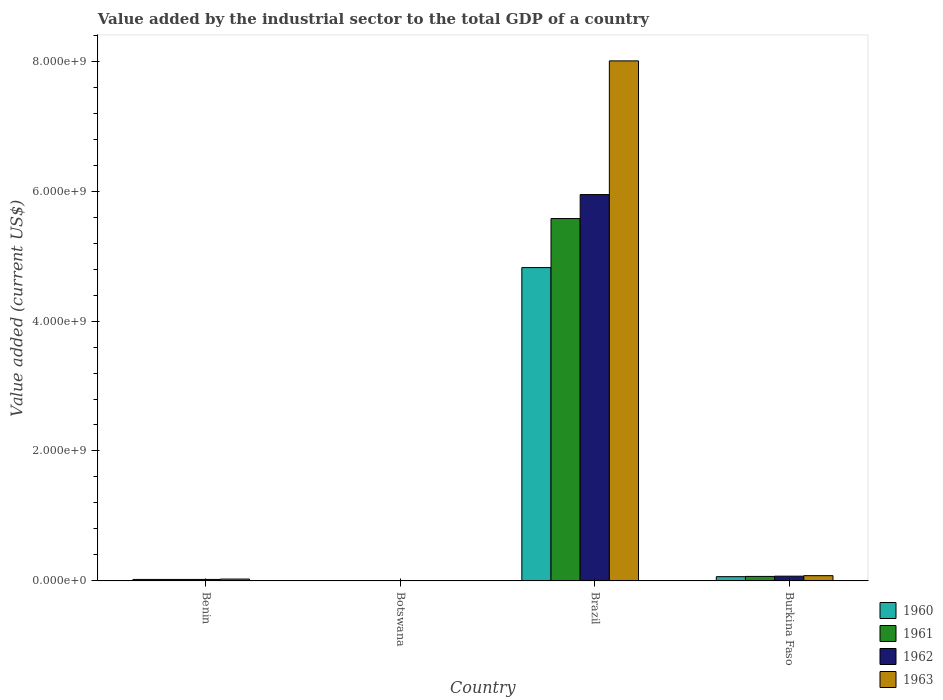How many different coloured bars are there?
Keep it short and to the point. 4. How many groups of bars are there?
Provide a succinct answer. 4. Are the number of bars on each tick of the X-axis equal?
Keep it short and to the point. Yes. In how many cases, is the number of bars for a given country not equal to the number of legend labels?
Provide a short and direct response. 0. What is the value added by the industrial sector to the total GDP in 1960 in Burkina Faso?
Your answer should be very brief. 6.58e+07. Across all countries, what is the maximum value added by the industrial sector to the total GDP in 1960?
Ensure brevity in your answer.  4.82e+09. Across all countries, what is the minimum value added by the industrial sector to the total GDP in 1962?
Offer a terse response. 4.05e+06. In which country was the value added by the industrial sector to the total GDP in 1963 maximum?
Give a very brief answer. Brazil. In which country was the value added by the industrial sector to the total GDP in 1961 minimum?
Offer a very short reply. Botswana. What is the total value added by the industrial sector to the total GDP in 1963 in the graph?
Offer a terse response. 8.12e+09. What is the difference between the value added by the industrial sector to the total GDP in 1962 in Botswana and that in Burkina Faso?
Offer a very short reply. -6.95e+07. What is the difference between the value added by the industrial sector to the total GDP in 1962 in Botswana and the value added by the industrial sector to the total GDP in 1961 in Brazil?
Keep it short and to the point. -5.57e+09. What is the average value added by the industrial sector to the total GDP in 1962 per country?
Keep it short and to the point. 1.51e+09. What is the difference between the value added by the industrial sector to the total GDP of/in 1963 and value added by the industrial sector to the total GDP of/in 1962 in Botswana?
Keep it short and to the point. -1.15e+04. What is the ratio of the value added by the industrial sector to the total GDP in 1963 in Botswana to that in Burkina Faso?
Offer a very short reply. 0.05. Is the value added by the industrial sector to the total GDP in 1961 in Botswana less than that in Brazil?
Keep it short and to the point. Yes. What is the difference between the highest and the second highest value added by the industrial sector to the total GDP in 1961?
Your answer should be compact. -4.66e+07. What is the difference between the highest and the lowest value added by the industrial sector to the total GDP in 1960?
Ensure brevity in your answer.  4.82e+09. Is it the case that in every country, the sum of the value added by the industrial sector to the total GDP in 1962 and value added by the industrial sector to the total GDP in 1963 is greater than the sum of value added by the industrial sector to the total GDP in 1960 and value added by the industrial sector to the total GDP in 1961?
Your answer should be compact. No. What does the 1st bar from the right in Burkina Faso represents?
Provide a short and direct response. 1963. Is it the case that in every country, the sum of the value added by the industrial sector to the total GDP in 1961 and value added by the industrial sector to the total GDP in 1962 is greater than the value added by the industrial sector to the total GDP in 1960?
Provide a succinct answer. Yes. How many bars are there?
Give a very brief answer. 16. Are all the bars in the graph horizontal?
Ensure brevity in your answer.  No. Are the values on the major ticks of Y-axis written in scientific E-notation?
Offer a very short reply. Yes. Does the graph contain grids?
Give a very brief answer. No. How are the legend labels stacked?
Offer a very short reply. Vertical. What is the title of the graph?
Your answer should be compact. Value added by the industrial sector to the total GDP of a country. Does "1998" appear as one of the legend labels in the graph?
Your response must be concise. No. What is the label or title of the X-axis?
Offer a very short reply. Country. What is the label or title of the Y-axis?
Make the answer very short. Value added (current US$). What is the Value added (current US$) in 1960 in Benin?
Provide a short and direct response. 2.31e+07. What is the Value added (current US$) of 1961 in Benin?
Your answer should be very brief. 2.31e+07. What is the Value added (current US$) of 1962 in Benin?
Provide a succinct answer. 2.32e+07. What is the Value added (current US$) in 1963 in Benin?
Ensure brevity in your answer.  2.91e+07. What is the Value added (current US$) of 1960 in Botswana?
Your answer should be very brief. 4.05e+06. What is the Value added (current US$) of 1961 in Botswana?
Provide a short and direct response. 4.05e+06. What is the Value added (current US$) in 1962 in Botswana?
Provide a succinct answer. 4.05e+06. What is the Value added (current US$) of 1963 in Botswana?
Your response must be concise. 4.04e+06. What is the Value added (current US$) in 1960 in Brazil?
Your response must be concise. 4.82e+09. What is the Value added (current US$) of 1961 in Brazil?
Provide a succinct answer. 5.58e+09. What is the Value added (current US$) of 1962 in Brazil?
Offer a very short reply. 5.95e+09. What is the Value added (current US$) in 1963 in Brazil?
Your answer should be very brief. 8.00e+09. What is the Value added (current US$) in 1960 in Burkina Faso?
Ensure brevity in your answer.  6.58e+07. What is the Value added (current US$) of 1961 in Burkina Faso?
Make the answer very short. 6.97e+07. What is the Value added (current US$) in 1962 in Burkina Faso?
Offer a very short reply. 7.35e+07. What is the Value added (current US$) in 1963 in Burkina Faso?
Make the answer very short. 8.13e+07. Across all countries, what is the maximum Value added (current US$) in 1960?
Ensure brevity in your answer.  4.82e+09. Across all countries, what is the maximum Value added (current US$) in 1961?
Keep it short and to the point. 5.58e+09. Across all countries, what is the maximum Value added (current US$) in 1962?
Ensure brevity in your answer.  5.95e+09. Across all countries, what is the maximum Value added (current US$) of 1963?
Keep it short and to the point. 8.00e+09. Across all countries, what is the minimum Value added (current US$) in 1960?
Your answer should be compact. 4.05e+06. Across all countries, what is the minimum Value added (current US$) in 1961?
Your response must be concise. 4.05e+06. Across all countries, what is the minimum Value added (current US$) in 1962?
Give a very brief answer. 4.05e+06. Across all countries, what is the minimum Value added (current US$) of 1963?
Keep it short and to the point. 4.04e+06. What is the total Value added (current US$) in 1960 in the graph?
Provide a short and direct response. 4.92e+09. What is the total Value added (current US$) of 1961 in the graph?
Make the answer very short. 5.67e+09. What is the total Value added (current US$) of 1962 in the graph?
Your response must be concise. 6.05e+09. What is the total Value added (current US$) in 1963 in the graph?
Provide a succinct answer. 8.12e+09. What is the difference between the Value added (current US$) of 1960 in Benin and that in Botswana?
Provide a short and direct response. 1.91e+07. What is the difference between the Value added (current US$) of 1961 in Benin and that in Botswana?
Provide a short and direct response. 1.91e+07. What is the difference between the Value added (current US$) of 1962 in Benin and that in Botswana?
Provide a succinct answer. 1.91e+07. What is the difference between the Value added (current US$) of 1963 in Benin and that in Botswana?
Give a very brief answer. 2.51e+07. What is the difference between the Value added (current US$) in 1960 in Benin and that in Brazil?
Keep it short and to the point. -4.80e+09. What is the difference between the Value added (current US$) of 1961 in Benin and that in Brazil?
Your answer should be very brief. -5.55e+09. What is the difference between the Value added (current US$) of 1962 in Benin and that in Brazil?
Keep it short and to the point. -5.92e+09. What is the difference between the Value added (current US$) in 1963 in Benin and that in Brazil?
Ensure brevity in your answer.  -7.97e+09. What is the difference between the Value added (current US$) of 1960 in Benin and that in Burkina Faso?
Provide a succinct answer. -4.27e+07. What is the difference between the Value added (current US$) of 1961 in Benin and that in Burkina Faso?
Your answer should be very brief. -4.66e+07. What is the difference between the Value added (current US$) in 1962 in Benin and that in Burkina Faso?
Your response must be concise. -5.04e+07. What is the difference between the Value added (current US$) of 1963 in Benin and that in Burkina Faso?
Offer a terse response. -5.21e+07. What is the difference between the Value added (current US$) of 1960 in Botswana and that in Brazil?
Offer a terse response. -4.82e+09. What is the difference between the Value added (current US$) of 1961 in Botswana and that in Brazil?
Your answer should be very brief. -5.57e+09. What is the difference between the Value added (current US$) in 1962 in Botswana and that in Brazil?
Ensure brevity in your answer.  -5.94e+09. What is the difference between the Value added (current US$) in 1963 in Botswana and that in Brazil?
Keep it short and to the point. -8.00e+09. What is the difference between the Value added (current US$) of 1960 in Botswana and that in Burkina Faso?
Keep it short and to the point. -6.17e+07. What is the difference between the Value added (current US$) in 1961 in Botswana and that in Burkina Faso?
Give a very brief answer. -6.56e+07. What is the difference between the Value added (current US$) of 1962 in Botswana and that in Burkina Faso?
Provide a short and direct response. -6.95e+07. What is the difference between the Value added (current US$) in 1963 in Botswana and that in Burkina Faso?
Provide a succinct answer. -7.72e+07. What is the difference between the Value added (current US$) of 1960 in Brazil and that in Burkina Faso?
Make the answer very short. 4.76e+09. What is the difference between the Value added (current US$) in 1961 in Brazil and that in Burkina Faso?
Ensure brevity in your answer.  5.51e+09. What is the difference between the Value added (current US$) of 1962 in Brazil and that in Burkina Faso?
Keep it short and to the point. 5.87e+09. What is the difference between the Value added (current US$) in 1963 in Brazil and that in Burkina Faso?
Offer a very short reply. 7.92e+09. What is the difference between the Value added (current US$) in 1960 in Benin and the Value added (current US$) in 1961 in Botswana?
Offer a terse response. 1.91e+07. What is the difference between the Value added (current US$) in 1960 in Benin and the Value added (current US$) in 1962 in Botswana?
Make the answer very short. 1.91e+07. What is the difference between the Value added (current US$) in 1960 in Benin and the Value added (current US$) in 1963 in Botswana?
Offer a terse response. 1.91e+07. What is the difference between the Value added (current US$) in 1961 in Benin and the Value added (current US$) in 1962 in Botswana?
Offer a terse response. 1.91e+07. What is the difference between the Value added (current US$) in 1961 in Benin and the Value added (current US$) in 1963 in Botswana?
Provide a succinct answer. 1.91e+07. What is the difference between the Value added (current US$) of 1962 in Benin and the Value added (current US$) of 1963 in Botswana?
Your answer should be very brief. 1.91e+07. What is the difference between the Value added (current US$) of 1960 in Benin and the Value added (current US$) of 1961 in Brazil?
Provide a short and direct response. -5.55e+09. What is the difference between the Value added (current US$) of 1960 in Benin and the Value added (current US$) of 1962 in Brazil?
Your response must be concise. -5.92e+09. What is the difference between the Value added (current US$) of 1960 in Benin and the Value added (current US$) of 1963 in Brazil?
Give a very brief answer. -7.98e+09. What is the difference between the Value added (current US$) in 1961 in Benin and the Value added (current US$) in 1962 in Brazil?
Offer a terse response. -5.92e+09. What is the difference between the Value added (current US$) of 1961 in Benin and the Value added (current US$) of 1963 in Brazil?
Offer a terse response. -7.98e+09. What is the difference between the Value added (current US$) in 1962 in Benin and the Value added (current US$) in 1963 in Brazil?
Keep it short and to the point. -7.98e+09. What is the difference between the Value added (current US$) in 1960 in Benin and the Value added (current US$) in 1961 in Burkina Faso?
Make the answer very short. -4.65e+07. What is the difference between the Value added (current US$) of 1960 in Benin and the Value added (current US$) of 1962 in Burkina Faso?
Your answer should be very brief. -5.04e+07. What is the difference between the Value added (current US$) in 1960 in Benin and the Value added (current US$) in 1963 in Burkina Faso?
Your answer should be very brief. -5.81e+07. What is the difference between the Value added (current US$) of 1961 in Benin and the Value added (current US$) of 1962 in Burkina Faso?
Give a very brief answer. -5.04e+07. What is the difference between the Value added (current US$) of 1961 in Benin and the Value added (current US$) of 1963 in Burkina Faso?
Your answer should be very brief. -5.81e+07. What is the difference between the Value added (current US$) in 1962 in Benin and the Value added (current US$) in 1963 in Burkina Faso?
Your response must be concise. -5.81e+07. What is the difference between the Value added (current US$) in 1960 in Botswana and the Value added (current US$) in 1961 in Brazil?
Offer a terse response. -5.57e+09. What is the difference between the Value added (current US$) of 1960 in Botswana and the Value added (current US$) of 1962 in Brazil?
Make the answer very short. -5.94e+09. What is the difference between the Value added (current US$) of 1960 in Botswana and the Value added (current US$) of 1963 in Brazil?
Your answer should be compact. -8.00e+09. What is the difference between the Value added (current US$) in 1961 in Botswana and the Value added (current US$) in 1962 in Brazil?
Offer a very short reply. -5.94e+09. What is the difference between the Value added (current US$) of 1961 in Botswana and the Value added (current US$) of 1963 in Brazil?
Offer a very short reply. -8.00e+09. What is the difference between the Value added (current US$) of 1962 in Botswana and the Value added (current US$) of 1963 in Brazil?
Provide a succinct answer. -8.00e+09. What is the difference between the Value added (current US$) of 1960 in Botswana and the Value added (current US$) of 1961 in Burkina Faso?
Your response must be concise. -6.56e+07. What is the difference between the Value added (current US$) of 1960 in Botswana and the Value added (current US$) of 1962 in Burkina Faso?
Offer a very short reply. -6.95e+07. What is the difference between the Value added (current US$) of 1960 in Botswana and the Value added (current US$) of 1963 in Burkina Faso?
Give a very brief answer. -7.72e+07. What is the difference between the Value added (current US$) of 1961 in Botswana and the Value added (current US$) of 1962 in Burkina Faso?
Your answer should be very brief. -6.95e+07. What is the difference between the Value added (current US$) of 1961 in Botswana and the Value added (current US$) of 1963 in Burkina Faso?
Your answer should be compact. -7.72e+07. What is the difference between the Value added (current US$) in 1962 in Botswana and the Value added (current US$) in 1963 in Burkina Faso?
Offer a terse response. -7.72e+07. What is the difference between the Value added (current US$) in 1960 in Brazil and the Value added (current US$) in 1961 in Burkina Faso?
Your response must be concise. 4.75e+09. What is the difference between the Value added (current US$) in 1960 in Brazil and the Value added (current US$) in 1962 in Burkina Faso?
Provide a succinct answer. 4.75e+09. What is the difference between the Value added (current US$) in 1960 in Brazil and the Value added (current US$) in 1963 in Burkina Faso?
Give a very brief answer. 4.74e+09. What is the difference between the Value added (current US$) in 1961 in Brazil and the Value added (current US$) in 1962 in Burkina Faso?
Make the answer very short. 5.50e+09. What is the difference between the Value added (current US$) in 1961 in Brazil and the Value added (current US$) in 1963 in Burkina Faso?
Provide a succinct answer. 5.50e+09. What is the difference between the Value added (current US$) of 1962 in Brazil and the Value added (current US$) of 1963 in Burkina Faso?
Your answer should be compact. 5.86e+09. What is the average Value added (current US$) in 1960 per country?
Provide a short and direct response. 1.23e+09. What is the average Value added (current US$) in 1961 per country?
Keep it short and to the point. 1.42e+09. What is the average Value added (current US$) in 1962 per country?
Make the answer very short. 1.51e+09. What is the average Value added (current US$) in 1963 per country?
Your answer should be compact. 2.03e+09. What is the difference between the Value added (current US$) of 1960 and Value added (current US$) of 1961 in Benin?
Offer a very short reply. 6130.83. What is the difference between the Value added (current US$) in 1960 and Value added (current US$) in 1962 in Benin?
Offer a very short reply. -1.71e+04. What is the difference between the Value added (current US$) of 1960 and Value added (current US$) of 1963 in Benin?
Your response must be concise. -5.99e+06. What is the difference between the Value added (current US$) of 1961 and Value added (current US$) of 1962 in Benin?
Offer a very short reply. -2.32e+04. What is the difference between the Value added (current US$) of 1961 and Value added (current US$) of 1963 in Benin?
Give a very brief answer. -6.00e+06. What is the difference between the Value added (current US$) in 1962 and Value added (current US$) in 1963 in Benin?
Offer a very short reply. -5.97e+06. What is the difference between the Value added (current US$) in 1960 and Value added (current US$) in 1961 in Botswana?
Keep it short and to the point. 7791.27. What is the difference between the Value added (current US$) in 1960 and Value added (current US$) in 1962 in Botswana?
Ensure brevity in your answer.  -314.81. What is the difference between the Value added (current US$) of 1960 and Value added (current US$) of 1963 in Botswana?
Make the answer very short. 1.11e+04. What is the difference between the Value added (current US$) in 1961 and Value added (current US$) in 1962 in Botswana?
Keep it short and to the point. -8106.08. What is the difference between the Value added (current US$) in 1961 and Value added (current US$) in 1963 in Botswana?
Provide a short and direct response. 3353.04. What is the difference between the Value added (current US$) in 1962 and Value added (current US$) in 1963 in Botswana?
Offer a very short reply. 1.15e+04. What is the difference between the Value added (current US$) in 1960 and Value added (current US$) in 1961 in Brazil?
Your response must be concise. -7.55e+08. What is the difference between the Value added (current US$) of 1960 and Value added (current US$) of 1962 in Brazil?
Your answer should be very brief. -1.12e+09. What is the difference between the Value added (current US$) of 1960 and Value added (current US$) of 1963 in Brazil?
Your response must be concise. -3.18e+09. What is the difference between the Value added (current US$) in 1961 and Value added (current US$) in 1962 in Brazil?
Offer a terse response. -3.69e+08. What is the difference between the Value added (current US$) in 1961 and Value added (current US$) in 1963 in Brazil?
Provide a short and direct response. -2.43e+09. What is the difference between the Value added (current US$) of 1962 and Value added (current US$) of 1963 in Brazil?
Make the answer very short. -2.06e+09. What is the difference between the Value added (current US$) in 1960 and Value added (current US$) in 1961 in Burkina Faso?
Offer a terse response. -3.88e+06. What is the difference between the Value added (current US$) in 1960 and Value added (current US$) in 1962 in Burkina Faso?
Your response must be concise. -7.71e+06. What is the difference between the Value added (current US$) in 1960 and Value added (current US$) in 1963 in Burkina Faso?
Your response must be concise. -1.55e+07. What is the difference between the Value added (current US$) in 1961 and Value added (current US$) in 1962 in Burkina Faso?
Offer a terse response. -3.83e+06. What is the difference between the Value added (current US$) of 1961 and Value added (current US$) of 1963 in Burkina Faso?
Provide a succinct answer. -1.16e+07. What is the difference between the Value added (current US$) in 1962 and Value added (current US$) in 1963 in Burkina Faso?
Offer a terse response. -7.75e+06. What is the ratio of the Value added (current US$) of 1960 in Benin to that in Botswana?
Ensure brevity in your answer.  5.71. What is the ratio of the Value added (current US$) in 1961 in Benin to that in Botswana?
Make the answer very short. 5.72. What is the ratio of the Value added (current US$) in 1962 in Benin to that in Botswana?
Offer a very short reply. 5.71. What is the ratio of the Value added (current US$) of 1963 in Benin to that in Botswana?
Offer a terse response. 7.2. What is the ratio of the Value added (current US$) of 1960 in Benin to that in Brazil?
Keep it short and to the point. 0. What is the ratio of the Value added (current US$) in 1961 in Benin to that in Brazil?
Offer a terse response. 0. What is the ratio of the Value added (current US$) in 1962 in Benin to that in Brazil?
Give a very brief answer. 0. What is the ratio of the Value added (current US$) of 1963 in Benin to that in Brazil?
Your answer should be compact. 0. What is the ratio of the Value added (current US$) in 1960 in Benin to that in Burkina Faso?
Provide a succinct answer. 0.35. What is the ratio of the Value added (current US$) in 1961 in Benin to that in Burkina Faso?
Your answer should be compact. 0.33. What is the ratio of the Value added (current US$) of 1962 in Benin to that in Burkina Faso?
Your response must be concise. 0.31. What is the ratio of the Value added (current US$) of 1963 in Benin to that in Burkina Faso?
Your answer should be compact. 0.36. What is the ratio of the Value added (current US$) in 1960 in Botswana to that in Brazil?
Provide a short and direct response. 0. What is the ratio of the Value added (current US$) in 1961 in Botswana to that in Brazil?
Offer a very short reply. 0. What is the ratio of the Value added (current US$) of 1962 in Botswana to that in Brazil?
Offer a very short reply. 0. What is the ratio of the Value added (current US$) of 1963 in Botswana to that in Brazil?
Provide a short and direct response. 0. What is the ratio of the Value added (current US$) in 1960 in Botswana to that in Burkina Faso?
Make the answer very short. 0.06. What is the ratio of the Value added (current US$) in 1961 in Botswana to that in Burkina Faso?
Make the answer very short. 0.06. What is the ratio of the Value added (current US$) in 1962 in Botswana to that in Burkina Faso?
Keep it short and to the point. 0.06. What is the ratio of the Value added (current US$) of 1963 in Botswana to that in Burkina Faso?
Your answer should be compact. 0.05. What is the ratio of the Value added (current US$) of 1960 in Brazil to that in Burkina Faso?
Ensure brevity in your answer.  73.29. What is the ratio of the Value added (current US$) in 1961 in Brazil to that in Burkina Faso?
Give a very brief answer. 80.04. What is the ratio of the Value added (current US$) in 1962 in Brazil to that in Burkina Faso?
Your response must be concise. 80.89. What is the ratio of the Value added (current US$) in 1963 in Brazil to that in Burkina Faso?
Your response must be concise. 98.49. What is the difference between the highest and the second highest Value added (current US$) in 1960?
Offer a very short reply. 4.76e+09. What is the difference between the highest and the second highest Value added (current US$) in 1961?
Your answer should be very brief. 5.51e+09. What is the difference between the highest and the second highest Value added (current US$) in 1962?
Offer a terse response. 5.87e+09. What is the difference between the highest and the second highest Value added (current US$) of 1963?
Give a very brief answer. 7.92e+09. What is the difference between the highest and the lowest Value added (current US$) in 1960?
Offer a terse response. 4.82e+09. What is the difference between the highest and the lowest Value added (current US$) in 1961?
Give a very brief answer. 5.57e+09. What is the difference between the highest and the lowest Value added (current US$) of 1962?
Your answer should be compact. 5.94e+09. What is the difference between the highest and the lowest Value added (current US$) in 1963?
Your answer should be compact. 8.00e+09. 